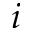<formula> <loc_0><loc_0><loc_500><loc_500>i</formula> 